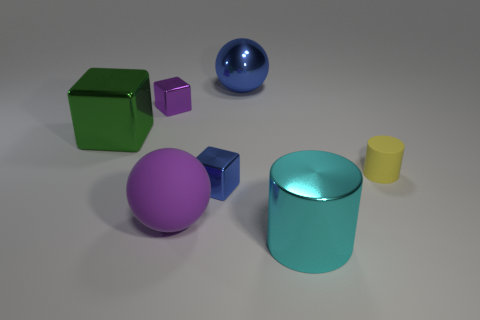How might these objects be used in a real-world setting? These objects could be used in various real-world settings. The cubes could function as dice in board games or educational tools for teaching math concepts. The spheres could be decorative elements in a home or garden. The cylinders might serve as simplistic representations of containers or stands in a design mockup. Their simplicity and clean lines suggest a utilitarian function, possibly as minimalist home decor or in a pedagogical context. 